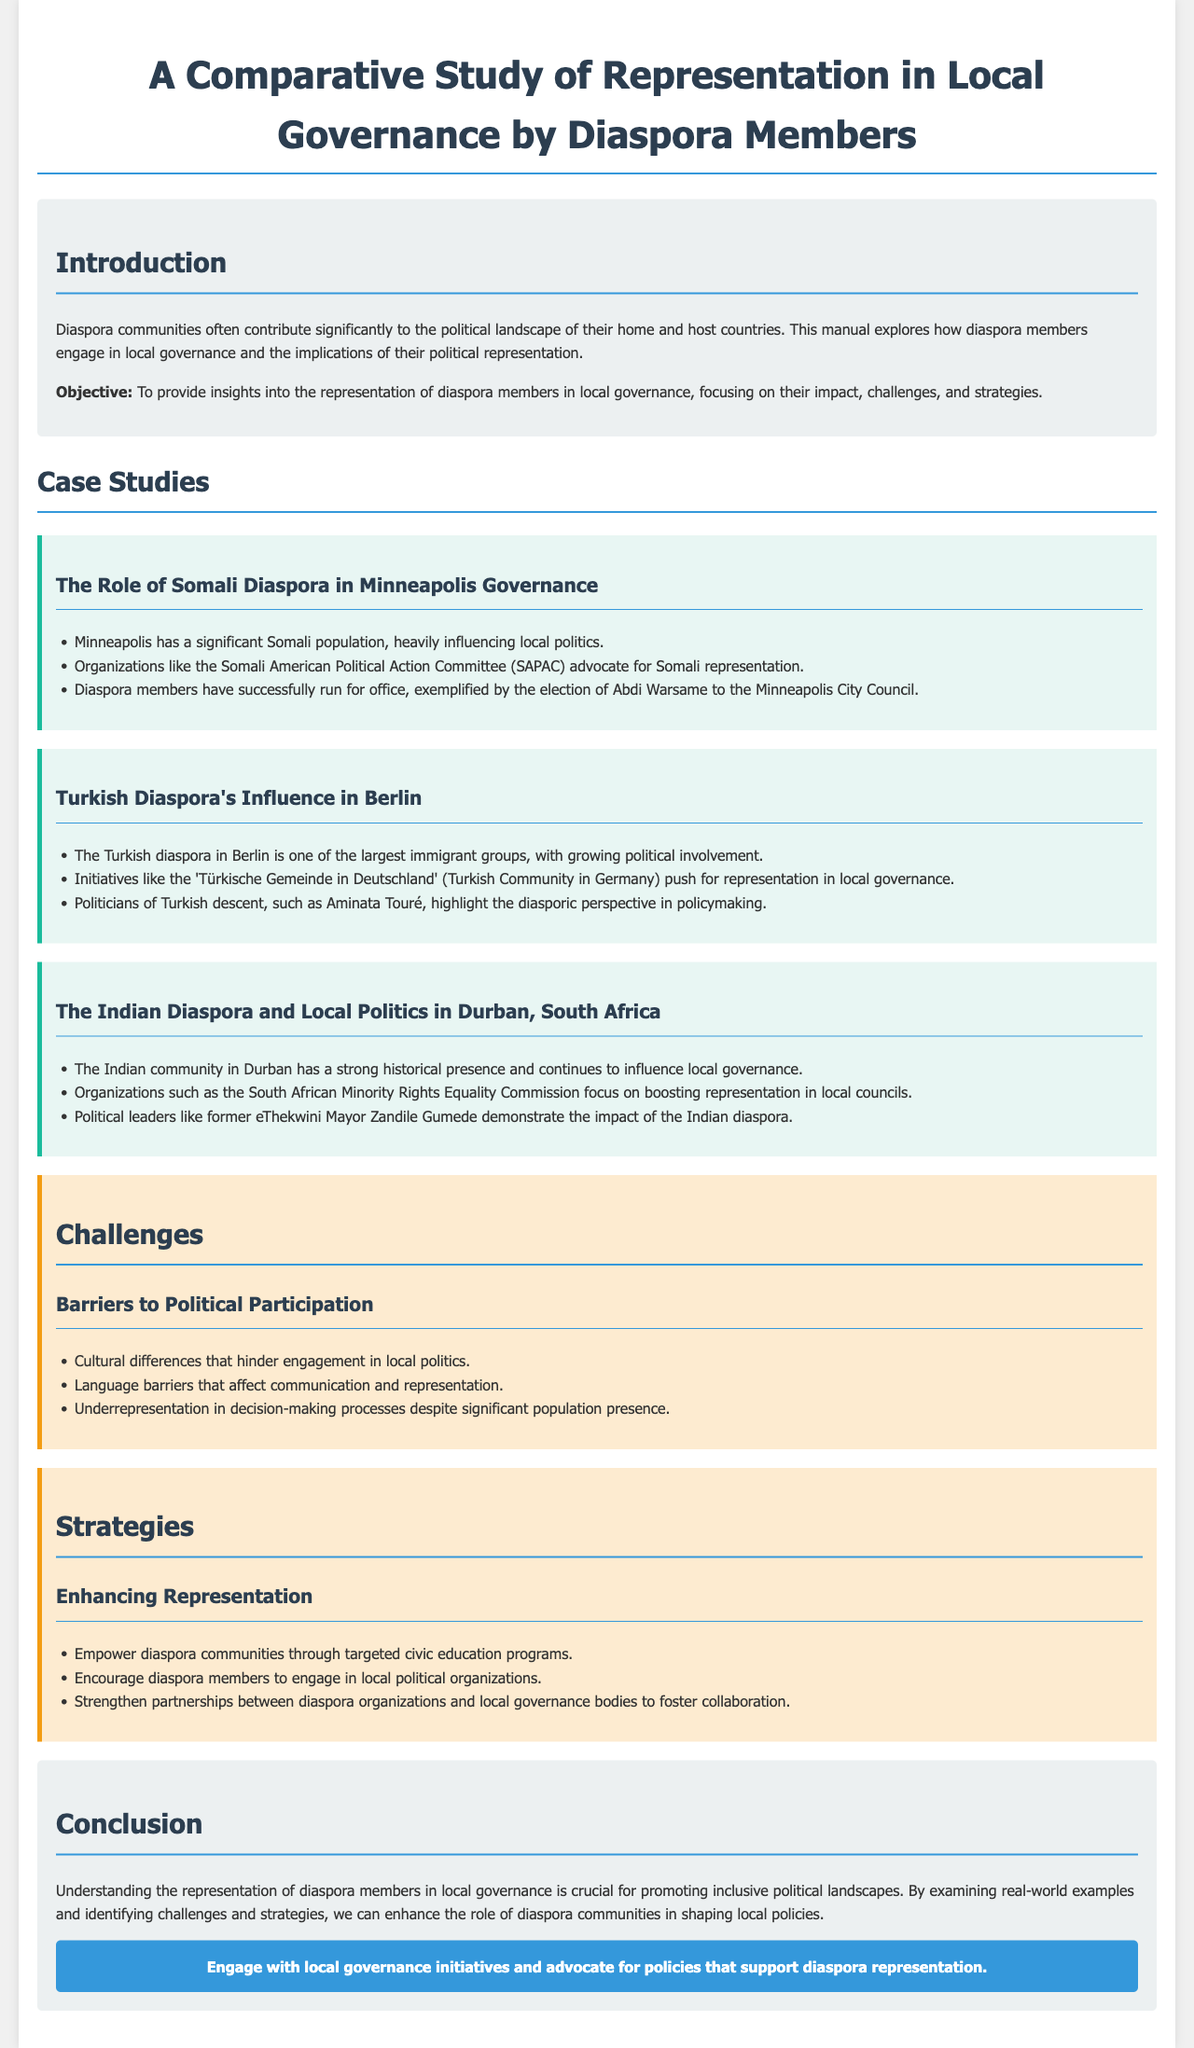What is the main objective of the manual? The main objective is to provide insights into the representation of diaspora members in local governance, focusing on their impact, challenges, and strategies.
Answer: to provide insights into the representation of diaspora members in local governance Who was elected to the Minneapolis City Council? Abdi Warsame was elected to the Minneapolis City Council as an example of successful diaspora representation.
Answer: Abdi Warsame What organization advocates for Somali representation in Minneapolis? The Somali American Political Action Committee (SAPAC) is mentioned as an advocate for Somali representation.
Answer: Somali American Political Action Committee (SAPAC) What is a barrier to political participation mentioned in the challenges section? Cultural differences are listed as a barrier to political participation.
Answer: Cultural differences What civic engagement strategy is suggested for diaspora communities? One strategy suggested is to empower diaspora communities through targeted civic education programs.
Answer: targeted civic education programs How many case studies are discussed in the manual? Three case studies are presented in the manual, focusing on different diaspora communities.
Answer: three Which city has a significant Indian diaspora influencing local governance? The Indian diaspora has a significant presence in Durban, South Africa.
Answer: Durban, South Africa What color is used for the background of the challenges section? The challenges section has a background color of light orange.
Answer: light orange 